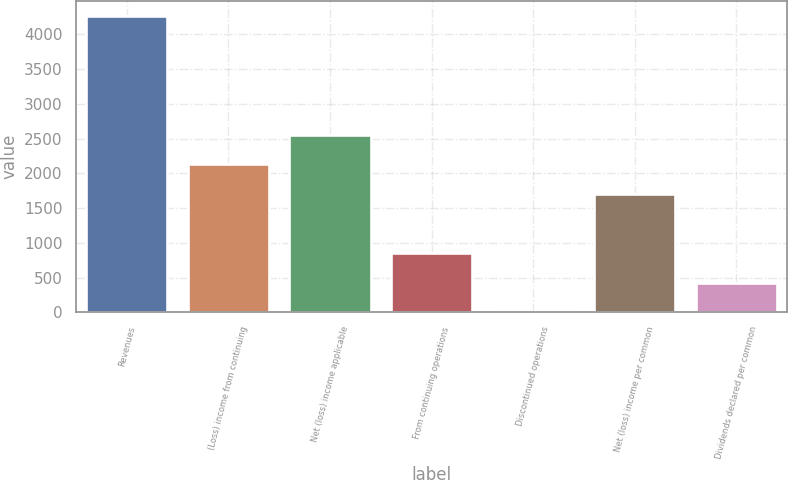Convert chart. <chart><loc_0><loc_0><loc_500><loc_500><bar_chart><fcel>Revenues<fcel>(Loss) income from continuing<fcel>Net (loss) income applicable<fcel>From continuing operations<fcel>Discontinued operations<fcel>Net (loss) income per common<fcel>Dividends declared per common<nl><fcel>4265<fcel>2132.55<fcel>2559.04<fcel>853.08<fcel>0.1<fcel>1706.06<fcel>426.59<nl></chart> 